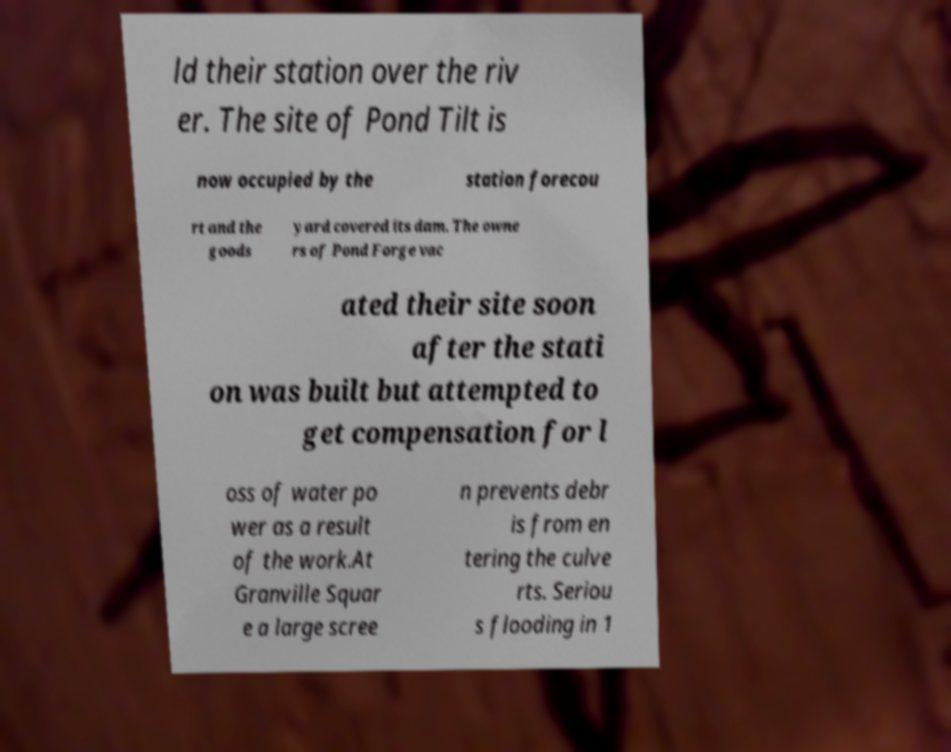Please identify and transcribe the text found in this image. ld their station over the riv er. The site of Pond Tilt is now occupied by the station forecou rt and the goods yard covered its dam. The owne rs of Pond Forge vac ated their site soon after the stati on was built but attempted to get compensation for l oss of water po wer as a result of the work.At Granville Squar e a large scree n prevents debr is from en tering the culve rts. Seriou s flooding in 1 